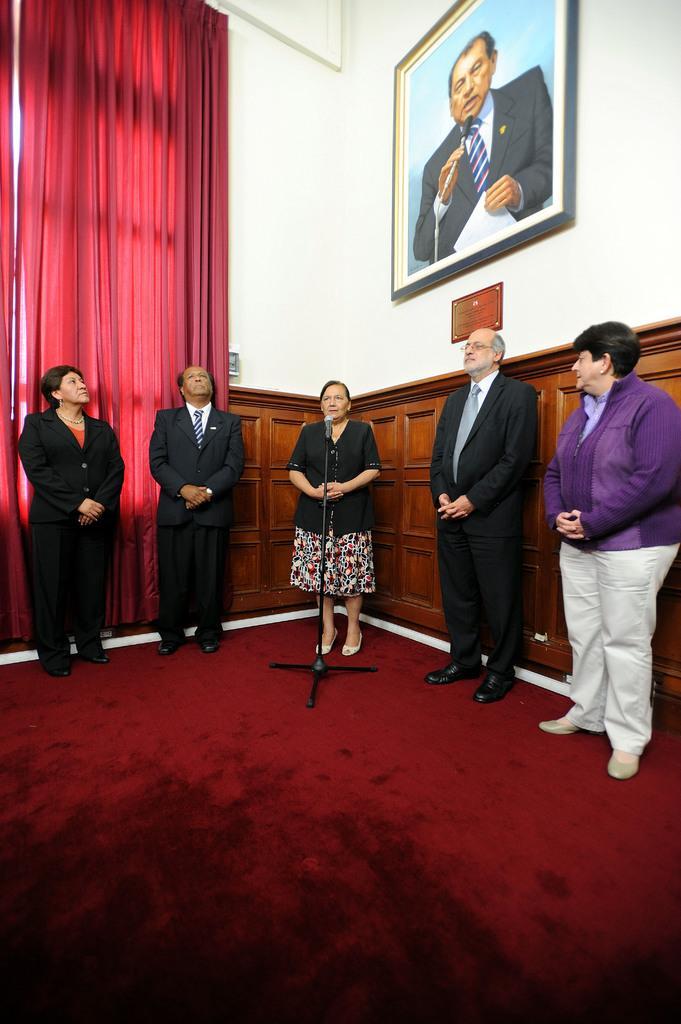Can you describe this image briefly? In this image we can see people standing on the floor and a mic is placed in front of one of them. In the background there are wall hangings to the wall and a curtain. 